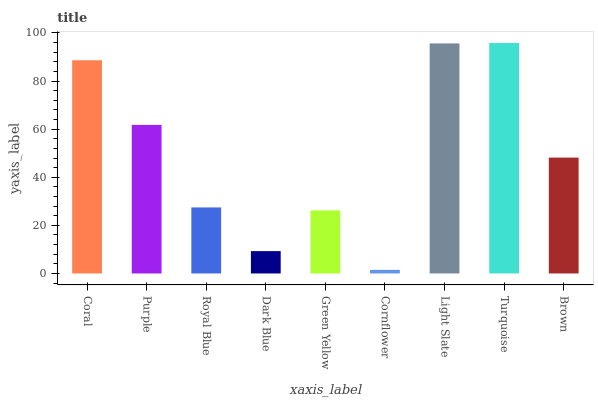Is Cornflower the minimum?
Answer yes or no. Yes. Is Turquoise the maximum?
Answer yes or no. Yes. Is Purple the minimum?
Answer yes or no. No. Is Purple the maximum?
Answer yes or no. No. Is Coral greater than Purple?
Answer yes or no. Yes. Is Purple less than Coral?
Answer yes or no. Yes. Is Purple greater than Coral?
Answer yes or no. No. Is Coral less than Purple?
Answer yes or no. No. Is Brown the high median?
Answer yes or no. Yes. Is Brown the low median?
Answer yes or no. Yes. Is Light Slate the high median?
Answer yes or no. No. Is Purple the low median?
Answer yes or no. No. 